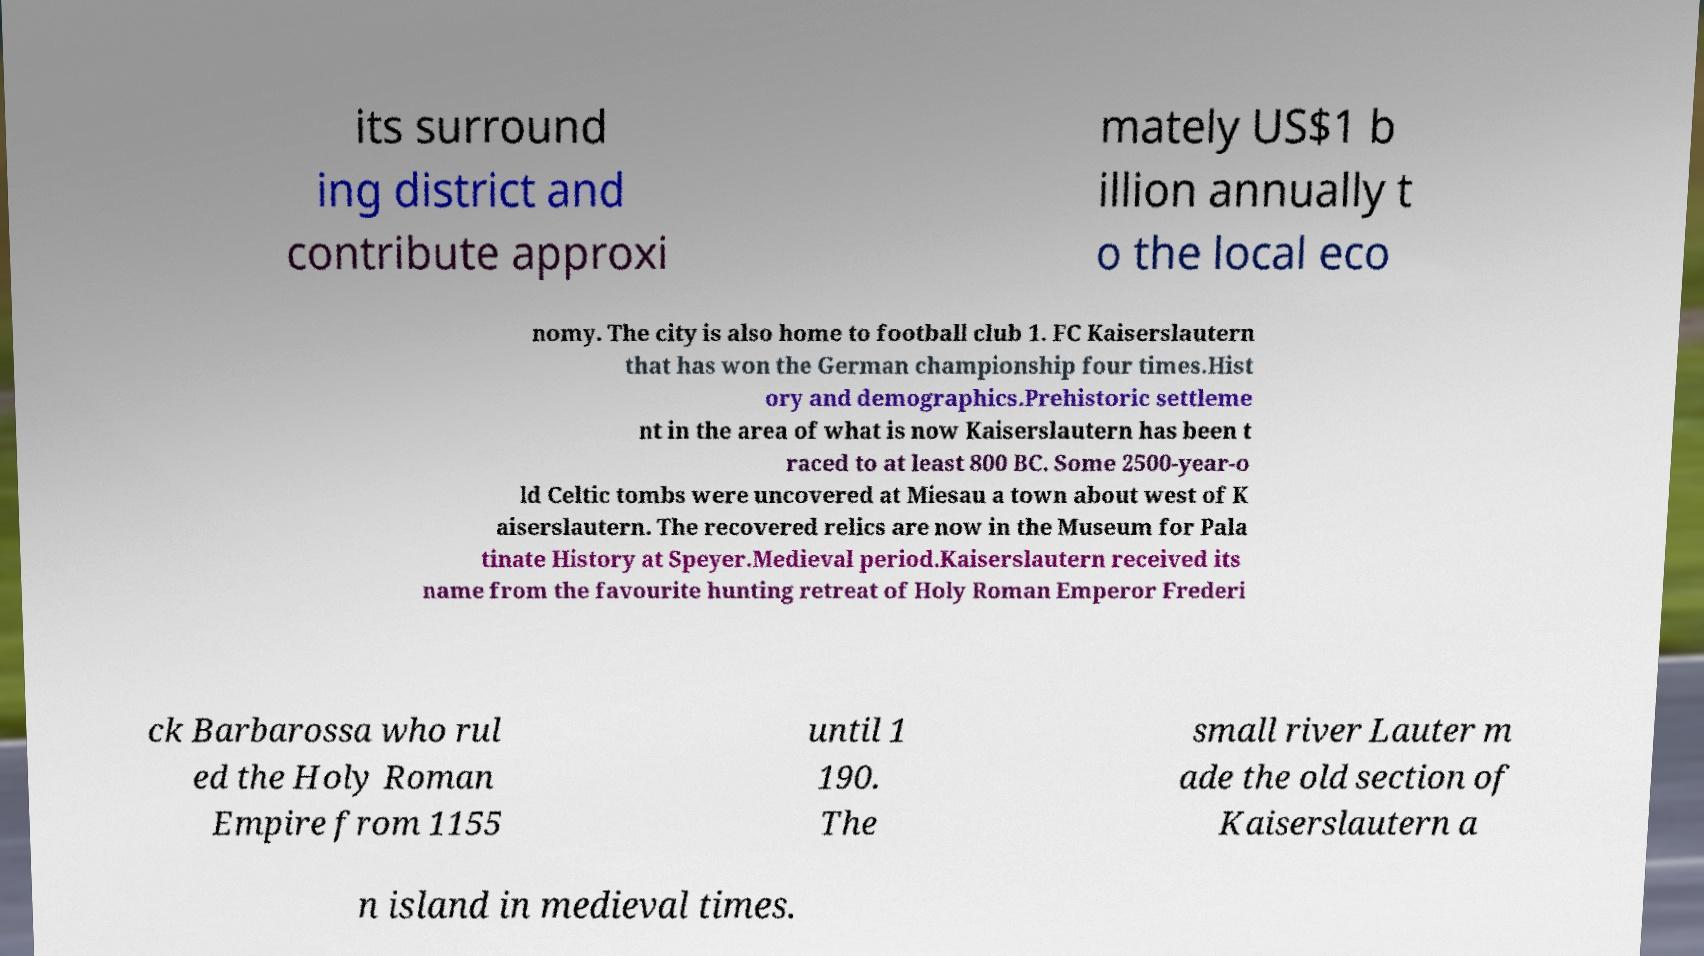Can you accurately transcribe the text from the provided image for me? its surround ing district and contribute approxi mately US$1 b illion annually t o the local eco nomy. The city is also home to football club 1. FC Kaiserslautern that has won the German championship four times.Hist ory and demographics.Prehistoric settleme nt in the area of what is now Kaiserslautern has been t raced to at least 800 BC. Some 2500-year-o ld Celtic tombs were uncovered at Miesau a town about west of K aiserslautern. The recovered relics are now in the Museum for Pala tinate History at Speyer.Medieval period.Kaiserslautern received its name from the favourite hunting retreat of Holy Roman Emperor Frederi ck Barbarossa who rul ed the Holy Roman Empire from 1155 until 1 190. The small river Lauter m ade the old section of Kaiserslautern a n island in medieval times. 